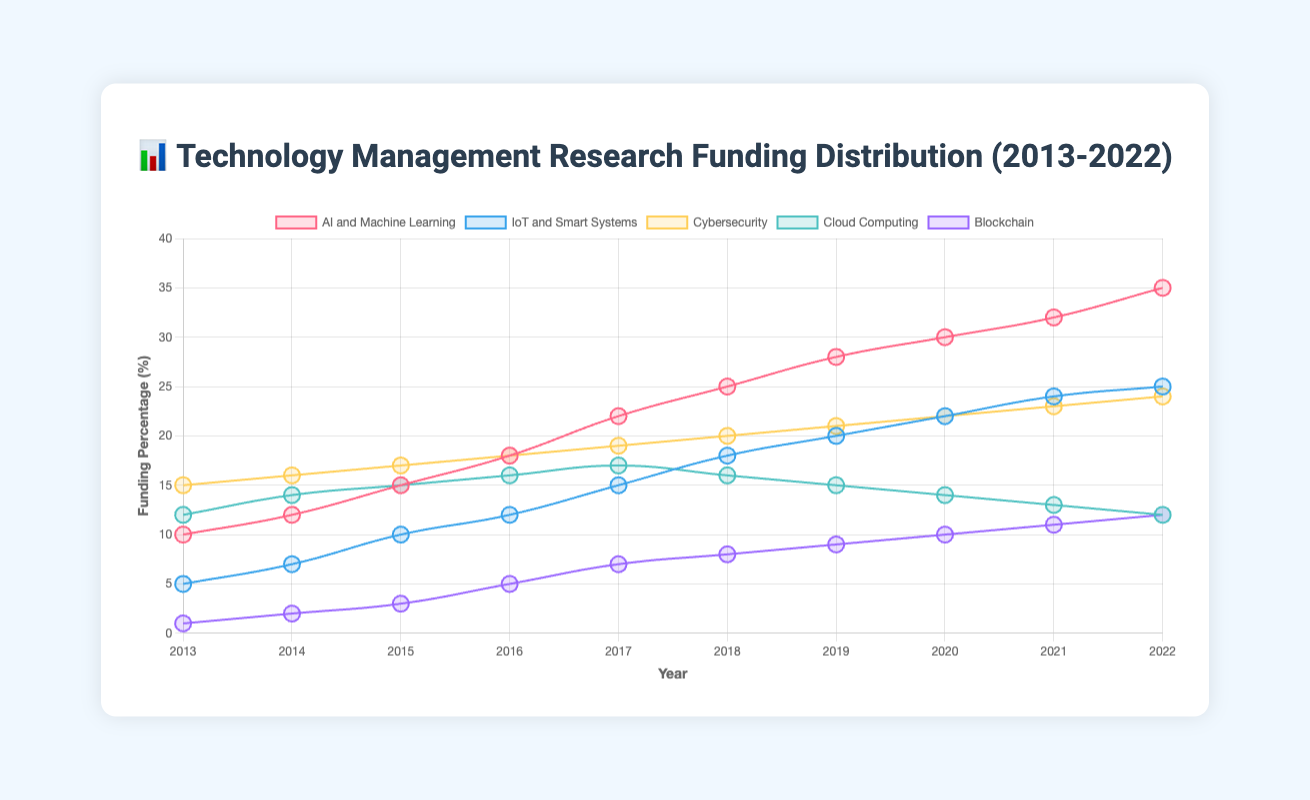what trend do you observe in the funding percentage for AI and Machine Learning? The funding percentage for AI and Machine Learning consistently increases each year from 2013 to 2022, starting at 10% and reaching 35%.
Answer: Increasing trend what is the difference in funding percentage between Cybersecurity and Blockchain in 2022? In 2022, Cybersecurity has a funding percentage of 24%, while Blockchain has 12%. The difference is 24% - 12% = 12%.
Answer: 12% which field had the most significant increase in funding percentage from 2013 to 2022? To find the most significant increase, subtract the funding percentage in 2013 from that in 2022 for each field. AI and Machine Learning increased from 10% to 35%, which is a 25% increase, the highest among all fields.
Answer: AI and Machine Learning what is the average funding percentage for Cloud Computing from 2013 to 2022? Sum the funding percentages for Cloud Computing from 2013 to 2022: 12 + 14 + 15 + 16 + 17 + 16 + 15 + 14 + 13 + 12 = 144. Then, divide by the number of years (10): 144/10 = 14.4%.
Answer: 14.4% how much more funding did AI and Machine Learning receive in 2022 compared to 2013? In 2022, AI and Machine Learning received 35%, whereas in 2013 it was 10%. The difference is 35% - 10% = 25%.
Answer: 25% which year had the highest funding for IoT and Smart Systems? By inspecting the IoT and Smart Systems funding percentages over the decade, the highest is 25% in 2022.
Answer: 2022 how does the funding for Blockchain compare to IoT and Smart Systems in 2016? In 2016, Blockchain received 5% funding while IoT and Smart Systems received 12%. Blockchain's funding was less.
Answer: Blockchain < IoT and Smart Systems what is the overall percentage increase in funding for Cybersecurity from 2013 to 2022? Cybersecurity's funding increased from 15% in 2013 to 24% in 2022. The overall increase is 24% - 15% = 9%.
Answer: 9% did any field's funding decrease over the years, and if so, which one? Cloud Computing's funding percentage decreased from 17% in 2017 to 12% in 2022.
Answer: Cloud Computing how many fields had a funding percentage of 20% or more in 2020? In 2020, AI and Machine Learning (30%), IoT and Smart Systems (22%), and Cybersecurity (22%) had a funding percentage of 20% or more. There are 3 fields.
Answer: 3 